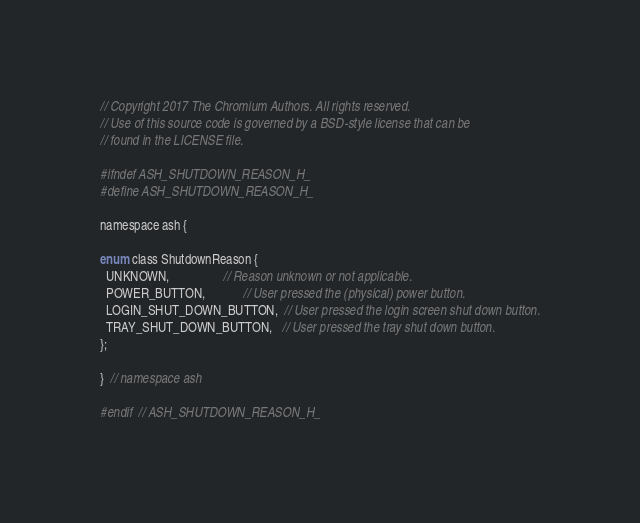<code> <loc_0><loc_0><loc_500><loc_500><_C_>// Copyright 2017 The Chromium Authors. All rights reserved.
// Use of this source code is governed by a BSD-style license that can be
// found in the LICENSE file.

#ifndef ASH_SHUTDOWN_REASON_H_
#define ASH_SHUTDOWN_REASON_H_

namespace ash {

enum class ShutdownReason {
  UNKNOWN,                 // Reason unknown or not applicable.
  POWER_BUTTON,            // User pressed the (physical) power button.
  LOGIN_SHUT_DOWN_BUTTON,  // User pressed the login screen shut down button.
  TRAY_SHUT_DOWN_BUTTON,   // User pressed the tray shut down button.
};

}  // namespace ash

#endif  // ASH_SHUTDOWN_REASON_H_
</code> 